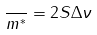<formula> <loc_0><loc_0><loc_500><loc_500>\frac { } { m ^ { * } } = 2 S \Delta \nu</formula> 